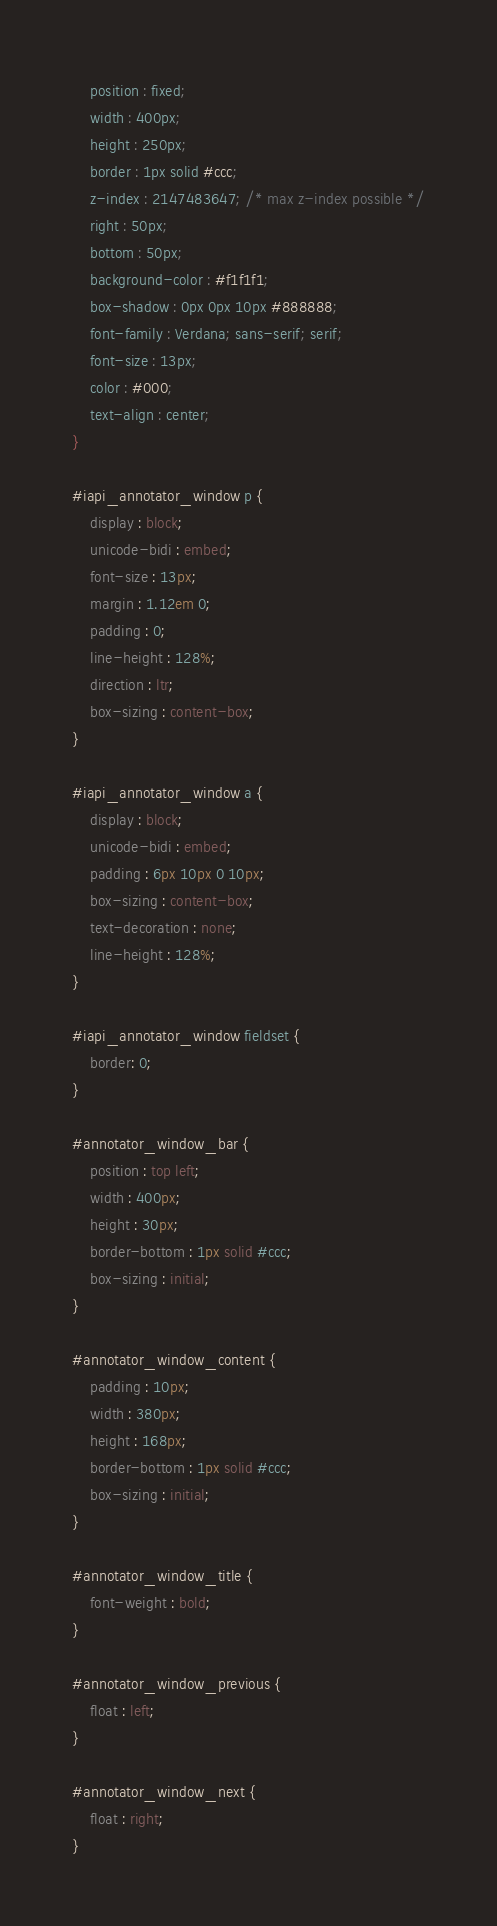Convert code to text. <code><loc_0><loc_0><loc_500><loc_500><_CSS_>	position : fixed;
	width : 400px;
	height : 250px;
	border : 1px solid #ccc;
	z-index : 2147483647; /* max z-index possible */
	right : 50px;
	bottom : 50px;
	background-color : #f1f1f1;
	box-shadow : 0px 0px 10px #888888;
	font-family : Verdana; sans-serif; serif;
	font-size : 13px;
	color : #000;
	text-align : center;
}

#iapi_annotator_window p {
	display : block;
	unicode-bidi : embed;
	font-size : 13px;
	margin : 1.12em 0;
	padding : 0;
	line-height : 128%;
	direction : ltr;
	box-sizing : content-box;
}

#iapi_annotator_window a {
	display : block;
	unicode-bidi : embed;
	padding : 6px 10px 0 10px;
	box-sizing : content-box;
	text-decoration : none;
	line-height : 128%;
}

#iapi_annotator_window fieldset {
	border: 0;
}

#annotator_window_bar {
	position : top left;
	width : 400px;
	height : 30px;
	border-bottom : 1px solid #ccc;
	box-sizing : initial;
}

#annotator_window_content {
	padding : 10px;
	width : 380px;
	height : 168px;
	border-bottom : 1px solid #ccc;
	box-sizing : initial;
}

#annotator_window_title {
	font-weight : bold;
}

#annotator_window_previous {
	float : left;
}

#annotator_window_next {
	float : right;
}
</code> 